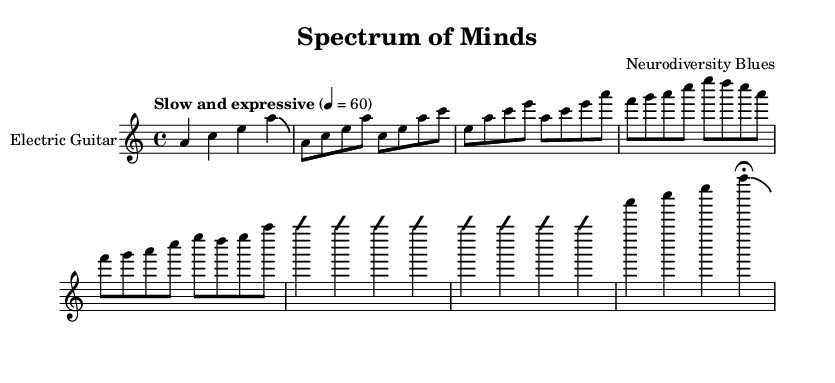What is the key signature of this music? The key signature indicates the tonal center and in this case is A minor, which consists of no sharps or flats. A minor can be identified as it has relative major, C major, with the same key signature.
Answer: A minor What is the time signature of this piece? The time signature indicates the rhythm structure of the music, and it is shown as 4/4. This means there are four beats in each measure and the quarter note gets one beat.
Answer: 4/4 What is the tempo marking of the piece? The tempo marking indicates the speed at which the piece is to be played. Here, it is marked as "Slow and expressive," with a metronome indication of 60 beats per minute. This generally equates to a slow feel for the music.
Answer: Slow and expressive How many bars are in the intro section? The intro section has one measure, as indicated by the single musical phrase before the vertical bar at the end. Each measure is separated by vertical lines (bar lines), so by counting, we find there is one bar.
Answer: 1 What is the overall structure of the music section? The structure can be inferred from its layout and includes an intro, a verse, a bridge, an improvised solo, and an outro. By identifying the specific sections, one can determine that it follows a typical narrative arc of Electric Blues.
Answer: Intro, Verse, Bridge, Solo, Outro Which technique is indicated by the notation "bendAfter"? The notation "bendAfter" is an electric guitar technique that indicates the player should bend the pitch of the note downwards before returning to the original pitch. This creates a soulful expression common in Blues music.
Answer: Bend What does the "fermata" symbol indicate at the end of the outro? The "fermata" symbol indicates a pause or holding of the note longer than its typical duration, allowing the performer to linger on that last note before ending the piece. This adds an emotional closure characteristic of Electric Blues.
Answer: Hold 